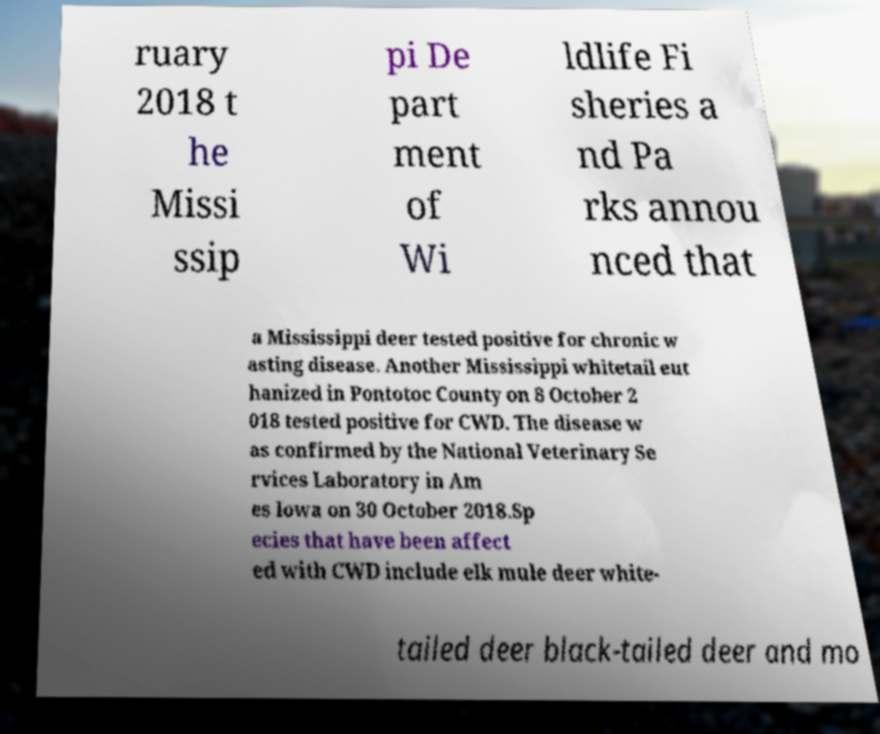For documentation purposes, I need the text within this image transcribed. Could you provide that? ruary 2018 t he Missi ssip pi De part ment of Wi ldlife Fi sheries a nd Pa rks annou nced that a Mississippi deer tested positive for chronic w asting disease. Another Mississippi whitetail eut hanized in Pontotoc County on 8 October 2 018 tested positive for CWD. The disease w as confirmed by the National Veterinary Se rvices Laboratory in Am es Iowa on 30 October 2018.Sp ecies that have been affect ed with CWD include elk mule deer white- tailed deer black-tailed deer and mo 